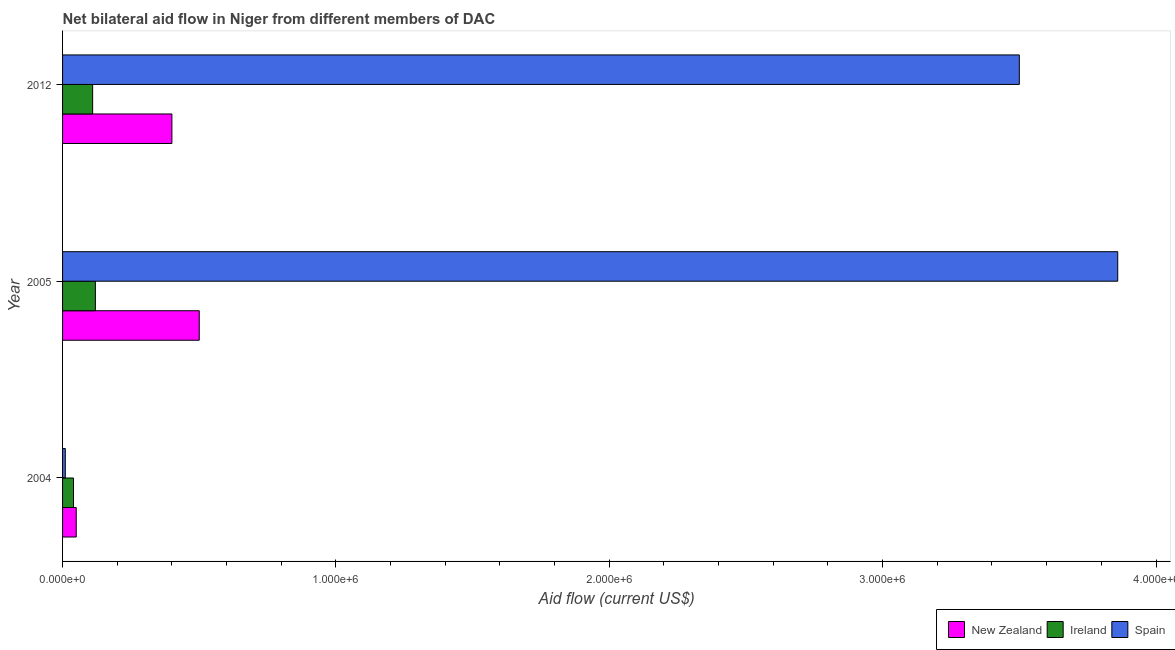How many different coloured bars are there?
Make the answer very short. 3. How many groups of bars are there?
Give a very brief answer. 3. How many bars are there on the 3rd tick from the top?
Give a very brief answer. 3. How many bars are there on the 3rd tick from the bottom?
Your response must be concise. 3. In how many cases, is the number of bars for a given year not equal to the number of legend labels?
Provide a short and direct response. 0. What is the amount of aid provided by new zealand in 2004?
Keep it short and to the point. 5.00e+04. Across all years, what is the maximum amount of aid provided by new zealand?
Offer a terse response. 5.00e+05. Across all years, what is the minimum amount of aid provided by spain?
Provide a short and direct response. 10000. What is the total amount of aid provided by spain in the graph?
Provide a succinct answer. 7.37e+06. What is the difference between the amount of aid provided by new zealand in 2004 and that in 2012?
Ensure brevity in your answer.  -3.50e+05. What is the difference between the amount of aid provided by spain in 2004 and the amount of aid provided by ireland in 2012?
Your answer should be very brief. -1.00e+05. What is the average amount of aid provided by new zealand per year?
Provide a succinct answer. 3.17e+05. In the year 2005, what is the difference between the amount of aid provided by ireland and amount of aid provided by spain?
Offer a very short reply. -3.74e+06. Is the amount of aid provided by spain in 2005 less than that in 2012?
Your answer should be very brief. No. What is the difference between the highest and the lowest amount of aid provided by spain?
Ensure brevity in your answer.  3.85e+06. Is the sum of the amount of aid provided by spain in 2004 and 2012 greater than the maximum amount of aid provided by new zealand across all years?
Make the answer very short. Yes. What does the 2nd bar from the top in 2012 represents?
Your response must be concise. Ireland. What does the 2nd bar from the bottom in 2005 represents?
Give a very brief answer. Ireland. Is it the case that in every year, the sum of the amount of aid provided by new zealand and amount of aid provided by ireland is greater than the amount of aid provided by spain?
Your answer should be very brief. No. Are all the bars in the graph horizontal?
Make the answer very short. Yes. How many years are there in the graph?
Give a very brief answer. 3. What is the difference between two consecutive major ticks on the X-axis?
Provide a succinct answer. 1.00e+06. Are the values on the major ticks of X-axis written in scientific E-notation?
Your answer should be compact. Yes. Does the graph contain grids?
Your answer should be compact. No. How are the legend labels stacked?
Your answer should be very brief. Horizontal. What is the title of the graph?
Give a very brief answer. Net bilateral aid flow in Niger from different members of DAC. Does "Oil sources" appear as one of the legend labels in the graph?
Keep it short and to the point. No. What is the label or title of the Y-axis?
Provide a short and direct response. Year. What is the Aid flow (current US$) of Ireland in 2004?
Offer a terse response. 4.00e+04. What is the Aid flow (current US$) in Spain in 2004?
Make the answer very short. 10000. What is the Aid flow (current US$) in New Zealand in 2005?
Provide a short and direct response. 5.00e+05. What is the Aid flow (current US$) of Spain in 2005?
Offer a terse response. 3.86e+06. What is the Aid flow (current US$) in New Zealand in 2012?
Ensure brevity in your answer.  4.00e+05. What is the Aid flow (current US$) in Spain in 2012?
Keep it short and to the point. 3.50e+06. Across all years, what is the maximum Aid flow (current US$) of New Zealand?
Offer a terse response. 5.00e+05. Across all years, what is the maximum Aid flow (current US$) in Spain?
Provide a short and direct response. 3.86e+06. Across all years, what is the minimum Aid flow (current US$) in Spain?
Provide a short and direct response. 10000. What is the total Aid flow (current US$) in New Zealand in the graph?
Your answer should be very brief. 9.50e+05. What is the total Aid flow (current US$) in Ireland in the graph?
Your response must be concise. 2.70e+05. What is the total Aid flow (current US$) in Spain in the graph?
Keep it short and to the point. 7.37e+06. What is the difference between the Aid flow (current US$) in New Zealand in 2004 and that in 2005?
Make the answer very short. -4.50e+05. What is the difference between the Aid flow (current US$) of Ireland in 2004 and that in 2005?
Your answer should be compact. -8.00e+04. What is the difference between the Aid flow (current US$) in Spain in 2004 and that in 2005?
Offer a very short reply. -3.85e+06. What is the difference between the Aid flow (current US$) in New Zealand in 2004 and that in 2012?
Give a very brief answer. -3.50e+05. What is the difference between the Aid flow (current US$) in Spain in 2004 and that in 2012?
Ensure brevity in your answer.  -3.49e+06. What is the difference between the Aid flow (current US$) in New Zealand in 2005 and that in 2012?
Provide a succinct answer. 1.00e+05. What is the difference between the Aid flow (current US$) in Spain in 2005 and that in 2012?
Your response must be concise. 3.60e+05. What is the difference between the Aid flow (current US$) in New Zealand in 2004 and the Aid flow (current US$) in Ireland in 2005?
Offer a very short reply. -7.00e+04. What is the difference between the Aid flow (current US$) in New Zealand in 2004 and the Aid flow (current US$) in Spain in 2005?
Your answer should be very brief. -3.81e+06. What is the difference between the Aid flow (current US$) of Ireland in 2004 and the Aid flow (current US$) of Spain in 2005?
Ensure brevity in your answer.  -3.82e+06. What is the difference between the Aid flow (current US$) in New Zealand in 2004 and the Aid flow (current US$) in Ireland in 2012?
Offer a terse response. -6.00e+04. What is the difference between the Aid flow (current US$) of New Zealand in 2004 and the Aid flow (current US$) of Spain in 2012?
Keep it short and to the point. -3.45e+06. What is the difference between the Aid flow (current US$) in Ireland in 2004 and the Aid flow (current US$) in Spain in 2012?
Provide a short and direct response. -3.46e+06. What is the difference between the Aid flow (current US$) in New Zealand in 2005 and the Aid flow (current US$) in Spain in 2012?
Give a very brief answer. -3.00e+06. What is the difference between the Aid flow (current US$) in Ireland in 2005 and the Aid flow (current US$) in Spain in 2012?
Provide a short and direct response. -3.38e+06. What is the average Aid flow (current US$) of New Zealand per year?
Your answer should be compact. 3.17e+05. What is the average Aid flow (current US$) of Spain per year?
Provide a succinct answer. 2.46e+06. In the year 2004, what is the difference between the Aid flow (current US$) of Ireland and Aid flow (current US$) of Spain?
Provide a succinct answer. 3.00e+04. In the year 2005, what is the difference between the Aid flow (current US$) of New Zealand and Aid flow (current US$) of Ireland?
Make the answer very short. 3.80e+05. In the year 2005, what is the difference between the Aid flow (current US$) of New Zealand and Aid flow (current US$) of Spain?
Make the answer very short. -3.36e+06. In the year 2005, what is the difference between the Aid flow (current US$) of Ireland and Aid flow (current US$) of Spain?
Provide a succinct answer. -3.74e+06. In the year 2012, what is the difference between the Aid flow (current US$) in New Zealand and Aid flow (current US$) in Spain?
Give a very brief answer. -3.10e+06. In the year 2012, what is the difference between the Aid flow (current US$) of Ireland and Aid flow (current US$) of Spain?
Your answer should be very brief. -3.39e+06. What is the ratio of the Aid flow (current US$) in New Zealand in 2004 to that in 2005?
Offer a terse response. 0.1. What is the ratio of the Aid flow (current US$) of Ireland in 2004 to that in 2005?
Make the answer very short. 0.33. What is the ratio of the Aid flow (current US$) of Spain in 2004 to that in 2005?
Provide a short and direct response. 0. What is the ratio of the Aid flow (current US$) in Ireland in 2004 to that in 2012?
Ensure brevity in your answer.  0.36. What is the ratio of the Aid flow (current US$) in Spain in 2004 to that in 2012?
Offer a very short reply. 0. What is the ratio of the Aid flow (current US$) of Ireland in 2005 to that in 2012?
Provide a short and direct response. 1.09. What is the ratio of the Aid flow (current US$) in Spain in 2005 to that in 2012?
Ensure brevity in your answer.  1.1. What is the difference between the highest and the second highest Aid flow (current US$) in New Zealand?
Provide a short and direct response. 1.00e+05. What is the difference between the highest and the second highest Aid flow (current US$) of Ireland?
Your response must be concise. 10000. What is the difference between the highest and the second highest Aid flow (current US$) in Spain?
Provide a short and direct response. 3.60e+05. What is the difference between the highest and the lowest Aid flow (current US$) of Spain?
Your answer should be very brief. 3.85e+06. 